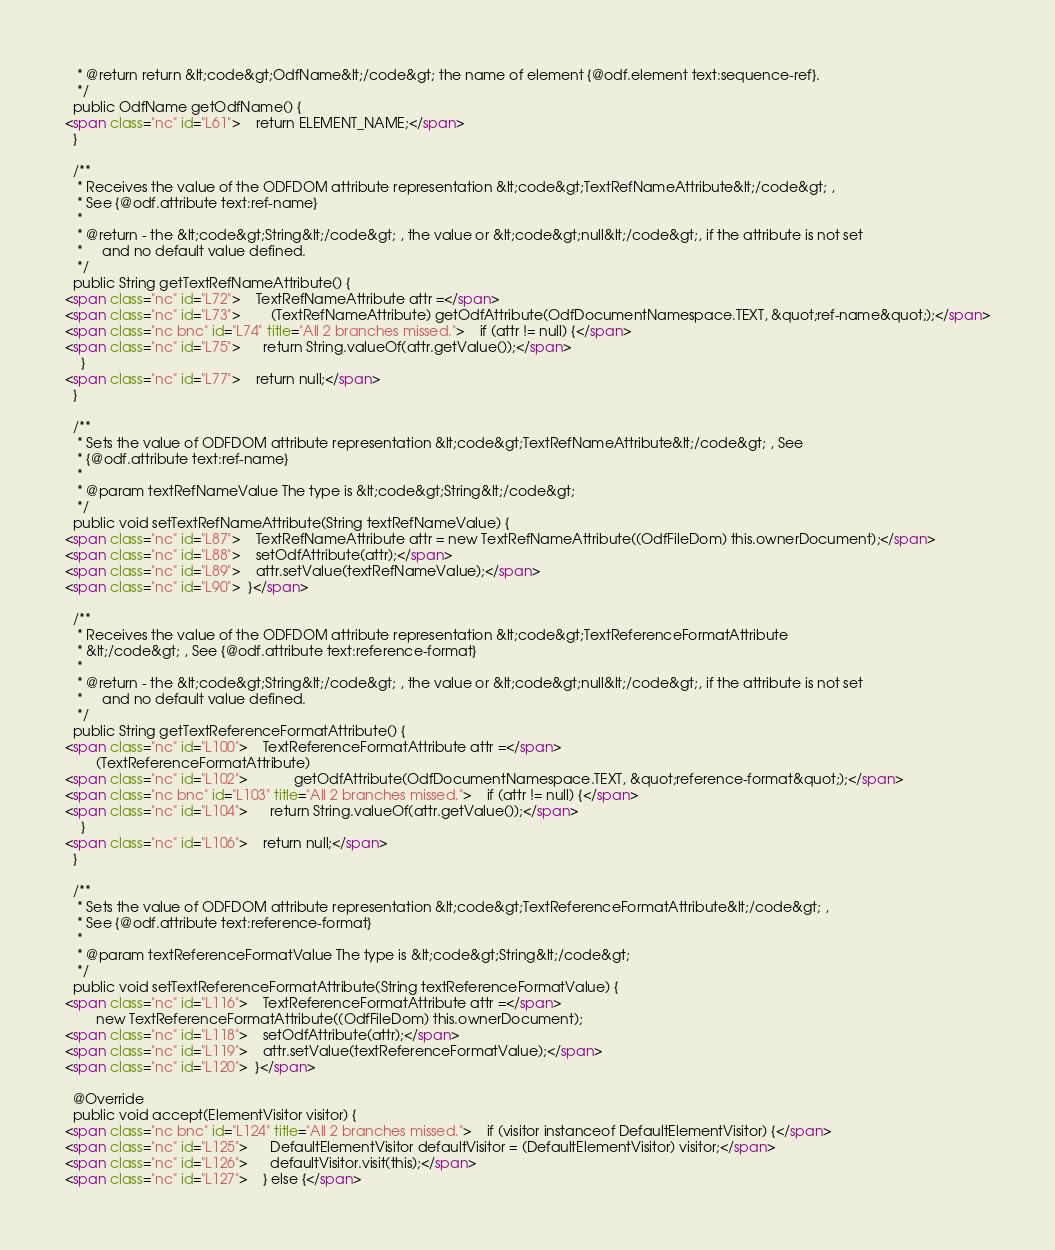Convert code to text. <code><loc_0><loc_0><loc_500><loc_500><_HTML_>   * @return return &lt;code&gt;OdfName&lt;/code&gt; the name of element {@odf.element text:sequence-ref}.
   */
  public OdfName getOdfName() {
<span class="nc" id="L61">    return ELEMENT_NAME;</span>
  }

  /**
   * Receives the value of the ODFDOM attribute representation &lt;code&gt;TextRefNameAttribute&lt;/code&gt; ,
   * See {@odf.attribute text:ref-name}
   *
   * @return - the &lt;code&gt;String&lt;/code&gt; , the value or &lt;code&gt;null&lt;/code&gt;, if the attribute is not set
   *     and no default value defined.
   */
  public String getTextRefNameAttribute() {
<span class="nc" id="L72">    TextRefNameAttribute attr =</span>
<span class="nc" id="L73">        (TextRefNameAttribute) getOdfAttribute(OdfDocumentNamespace.TEXT, &quot;ref-name&quot;);</span>
<span class="nc bnc" id="L74" title="All 2 branches missed.">    if (attr != null) {</span>
<span class="nc" id="L75">      return String.valueOf(attr.getValue());</span>
    }
<span class="nc" id="L77">    return null;</span>
  }

  /**
   * Sets the value of ODFDOM attribute representation &lt;code&gt;TextRefNameAttribute&lt;/code&gt; , See
   * {@odf.attribute text:ref-name}
   *
   * @param textRefNameValue The type is &lt;code&gt;String&lt;/code&gt;
   */
  public void setTextRefNameAttribute(String textRefNameValue) {
<span class="nc" id="L87">    TextRefNameAttribute attr = new TextRefNameAttribute((OdfFileDom) this.ownerDocument);</span>
<span class="nc" id="L88">    setOdfAttribute(attr);</span>
<span class="nc" id="L89">    attr.setValue(textRefNameValue);</span>
<span class="nc" id="L90">  }</span>

  /**
   * Receives the value of the ODFDOM attribute representation &lt;code&gt;TextReferenceFormatAttribute
   * &lt;/code&gt; , See {@odf.attribute text:reference-format}
   *
   * @return - the &lt;code&gt;String&lt;/code&gt; , the value or &lt;code&gt;null&lt;/code&gt;, if the attribute is not set
   *     and no default value defined.
   */
  public String getTextReferenceFormatAttribute() {
<span class="nc" id="L100">    TextReferenceFormatAttribute attr =</span>
        (TextReferenceFormatAttribute)
<span class="nc" id="L102">            getOdfAttribute(OdfDocumentNamespace.TEXT, &quot;reference-format&quot;);</span>
<span class="nc bnc" id="L103" title="All 2 branches missed.">    if (attr != null) {</span>
<span class="nc" id="L104">      return String.valueOf(attr.getValue());</span>
    }
<span class="nc" id="L106">    return null;</span>
  }

  /**
   * Sets the value of ODFDOM attribute representation &lt;code&gt;TextReferenceFormatAttribute&lt;/code&gt; ,
   * See {@odf.attribute text:reference-format}
   *
   * @param textReferenceFormatValue The type is &lt;code&gt;String&lt;/code&gt;
   */
  public void setTextReferenceFormatAttribute(String textReferenceFormatValue) {
<span class="nc" id="L116">    TextReferenceFormatAttribute attr =</span>
        new TextReferenceFormatAttribute((OdfFileDom) this.ownerDocument);
<span class="nc" id="L118">    setOdfAttribute(attr);</span>
<span class="nc" id="L119">    attr.setValue(textReferenceFormatValue);</span>
<span class="nc" id="L120">  }</span>

  @Override
  public void accept(ElementVisitor visitor) {
<span class="nc bnc" id="L124" title="All 2 branches missed.">    if (visitor instanceof DefaultElementVisitor) {</span>
<span class="nc" id="L125">      DefaultElementVisitor defaultVisitor = (DefaultElementVisitor) visitor;</span>
<span class="nc" id="L126">      defaultVisitor.visit(this);</span>
<span class="nc" id="L127">    } else {</span></code> 